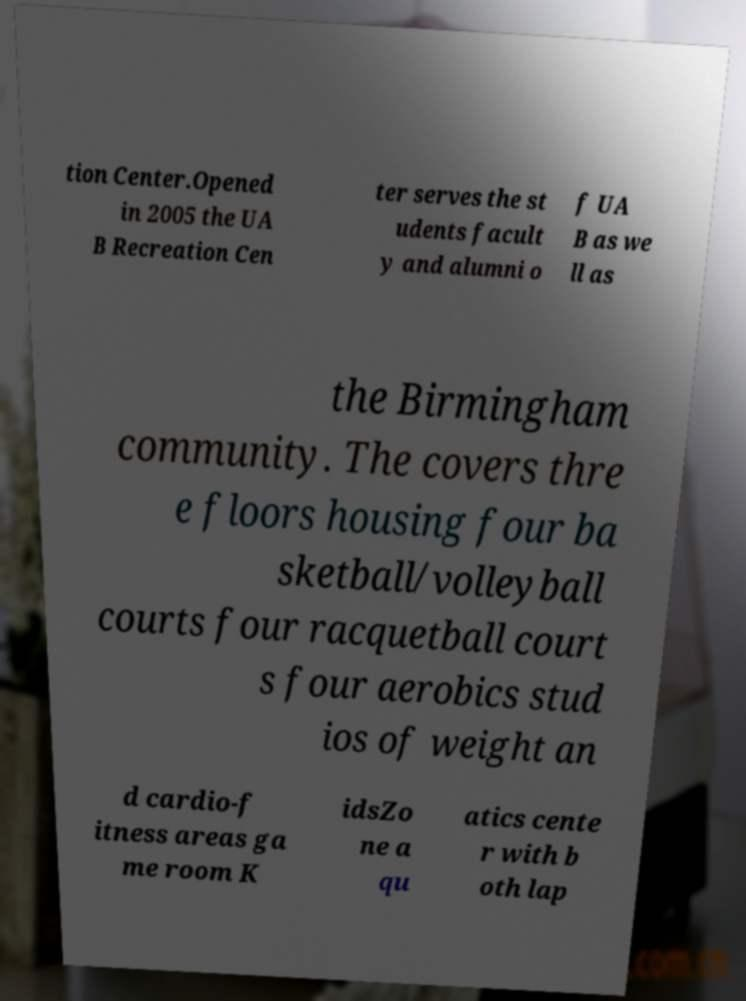There's text embedded in this image that I need extracted. Can you transcribe it verbatim? tion Center.Opened in 2005 the UA B Recreation Cen ter serves the st udents facult y and alumni o f UA B as we ll as the Birmingham community. The covers thre e floors housing four ba sketball/volleyball courts four racquetball court s four aerobics stud ios of weight an d cardio-f itness areas ga me room K idsZo ne a qu atics cente r with b oth lap 